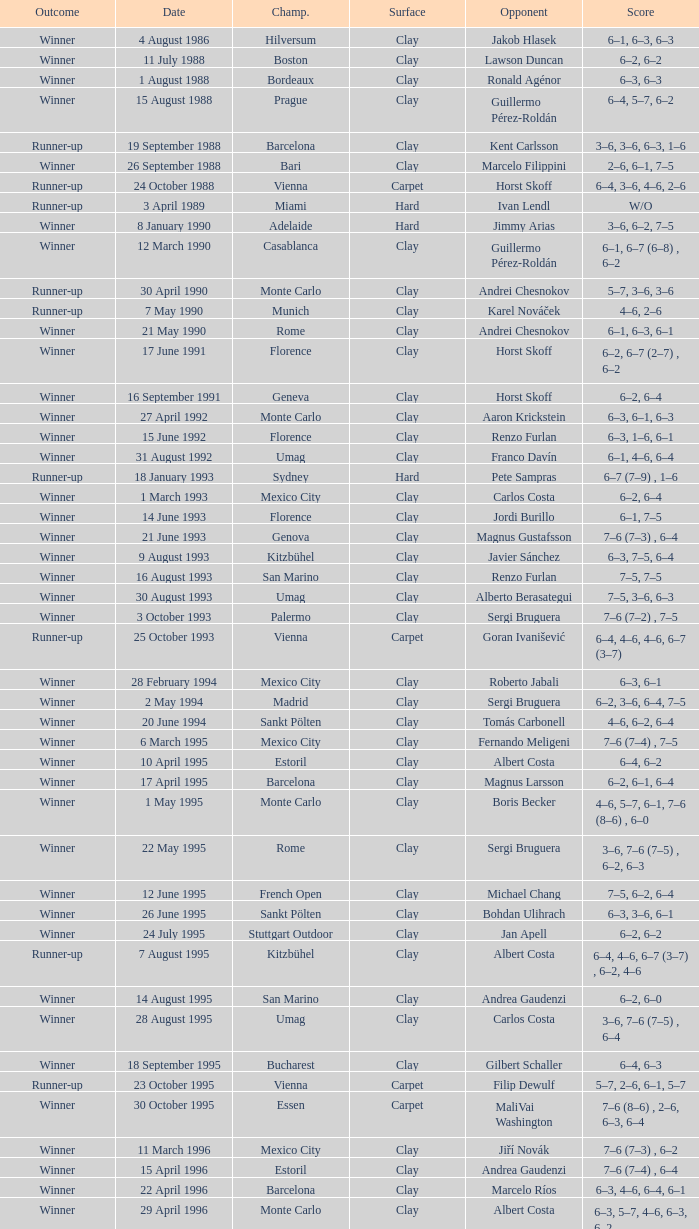Would you be able to parse every entry in this table? {'header': ['Outcome', 'Date', 'Champ.', 'Surface', 'Opponent', 'Score'], 'rows': [['Winner', '4 August 1986', 'Hilversum', 'Clay', 'Jakob Hlasek', '6–1, 6–3, 6–3'], ['Winner', '11 July 1988', 'Boston', 'Clay', 'Lawson Duncan', '6–2, 6–2'], ['Winner', '1 August 1988', 'Bordeaux', 'Clay', 'Ronald Agénor', '6–3, 6–3'], ['Winner', '15 August 1988', 'Prague', 'Clay', 'Guillermo Pérez-Roldán', '6–4, 5–7, 6–2'], ['Runner-up', '19 September 1988', 'Barcelona', 'Clay', 'Kent Carlsson', '3–6, 3–6, 6–3, 1–6'], ['Winner', '26 September 1988', 'Bari', 'Clay', 'Marcelo Filippini', '2–6, 6–1, 7–5'], ['Runner-up', '24 October 1988', 'Vienna', 'Carpet', 'Horst Skoff', '6–4, 3–6, 4–6, 2–6'], ['Runner-up', '3 April 1989', 'Miami', 'Hard', 'Ivan Lendl', 'W/O'], ['Winner', '8 January 1990', 'Adelaide', 'Hard', 'Jimmy Arias', '3–6, 6–2, 7–5'], ['Winner', '12 March 1990', 'Casablanca', 'Clay', 'Guillermo Pérez-Roldán', '6–1, 6–7 (6–8) , 6–2'], ['Runner-up', '30 April 1990', 'Monte Carlo', 'Clay', 'Andrei Chesnokov', '5–7, 3–6, 3–6'], ['Runner-up', '7 May 1990', 'Munich', 'Clay', 'Karel Nováček', '4–6, 2–6'], ['Winner', '21 May 1990', 'Rome', 'Clay', 'Andrei Chesnokov', '6–1, 6–3, 6–1'], ['Winner', '17 June 1991', 'Florence', 'Clay', 'Horst Skoff', '6–2, 6–7 (2–7) , 6–2'], ['Winner', '16 September 1991', 'Geneva', 'Clay', 'Horst Skoff', '6–2, 6–4'], ['Winner', '27 April 1992', 'Monte Carlo', 'Clay', 'Aaron Krickstein', '6–3, 6–1, 6–3'], ['Winner', '15 June 1992', 'Florence', 'Clay', 'Renzo Furlan', '6–3, 1–6, 6–1'], ['Winner', '31 August 1992', 'Umag', 'Clay', 'Franco Davín', '6–1, 4–6, 6–4'], ['Runner-up', '18 January 1993', 'Sydney', 'Hard', 'Pete Sampras', '6–7 (7–9) , 1–6'], ['Winner', '1 March 1993', 'Mexico City', 'Clay', 'Carlos Costa', '6–2, 6–4'], ['Winner', '14 June 1993', 'Florence', 'Clay', 'Jordi Burillo', '6–1, 7–5'], ['Winner', '21 June 1993', 'Genova', 'Clay', 'Magnus Gustafsson', '7–6 (7–3) , 6–4'], ['Winner', '9 August 1993', 'Kitzbühel', 'Clay', 'Javier Sánchez', '6–3, 7–5, 6–4'], ['Winner', '16 August 1993', 'San Marino', 'Clay', 'Renzo Furlan', '7–5, 7–5'], ['Winner', '30 August 1993', 'Umag', 'Clay', 'Alberto Berasategui', '7–5, 3–6, 6–3'], ['Winner', '3 October 1993', 'Palermo', 'Clay', 'Sergi Bruguera', '7–6 (7–2) , 7–5'], ['Runner-up', '25 October 1993', 'Vienna', 'Carpet', 'Goran Ivanišević', '6–4, 4–6, 4–6, 6–7 (3–7)'], ['Winner', '28 February 1994', 'Mexico City', 'Clay', 'Roberto Jabali', '6–3, 6–1'], ['Winner', '2 May 1994', 'Madrid', 'Clay', 'Sergi Bruguera', '6–2, 3–6, 6–4, 7–5'], ['Winner', '20 June 1994', 'Sankt Pölten', 'Clay', 'Tomás Carbonell', '4–6, 6–2, 6–4'], ['Winner', '6 March 1995', 'Mexico City', 'Clay', 'Fernando Meligeni', '7–6 (7–4) , 7–5'], ['Winner', '10 April 1995', 'Estoril', 'Clay', 'Albert Costa', '6–4, 6–2'], ['Winner', '17 April 1995', 'Barcelona', 'Clay', 'Magnus Larsson', '6–2, 6–1, 6–4'], ['Winner', '1 May 1995', 'Monte Carlo', 'Clay', 'Boris Becker', '4–6, 5–7, 6–1, 7–6 (8–6) , 6–0'], ['Winner', '22 May 1995', 'Rome', 'Clay', 'Sergi Bruguera', '3–6, 7–6 (7–5) , 6–2, 6–3'], ['Winner', '12 June 1995', 'French Open', 'Clay', 'Michael Chang', '7–5, 6–2, 6–4'], ['Winner', '26 June 1995', 'Sankt Pölten', 'Clay', 'Bohdan Ulihrach', '6–3, 3–6, 6–1'], ['Winner', '24 July 1995', 'Stuttgart Outdoor', 'Clay', 'Jan Apell', '6–2, 6–2'], ['Runner-up', '7 August 1995', 'Kitzbühel', 'Clay', 'Albert Costa', '6–4, 4–6, 6–7 (3–7) , 6–2, 4–6'], ['Winner', '14 August 1995', 'San Marino', 'Clay', 'Andrea Gaudenzi', '6–2, 6–0'], ['Winner', '28 August 1995', 'Umag', 'Clay', 'Carlos Costa', '3–6, 7–6 (7–5) , 6–4'], ['Winner', '18 September 1995', 'Bucharest', 'Clay', 'Gilbert Schaller', '6–4, 6–3'], ['Runner-up', '23 October 1995', 'Vienna', 'Carpet', 'Filip Dewulf', '5–7, 2–6, 6–1, 5–7'], ['Winner', '30 October 1995', 'Essen', 'Carpet', 'MaliVai Washington', '7–6 (8–6) , 2–6, 6–3, 6–4'], ['Winner', '11 March 1996', 'Mexico City', 'Clay', 'Jiří Novák', '7–6 (7–3) , 6–2'], ['Winner', '15 April 1996', 'Estoril', 'Clay', 'Andrea Gaudenzi', '7–6 (7–4) , 6–4'], ['Winner', '22 April 1996', 'Barcelona', 'Clay', 'Marcelo Ríos', '6–3, 4–6, 6–4, 6–1'], ['Winner', '29 April 1996', 'Monte Carlo', 'Clay', 'Albert Costa', '6–3, 5–7, 4–6, 6–3, 6–2'], ['Winner', '20 May 1996', 'Rome', 'Clay', 'Richard Krajicek', '6–2, 6–4, 3–6, 6–3'], ['Winner', '22 July 1996', 'Stuttgart Outdoor', 'Clay', 'Yevgeny Kafelnikov', '6–2, 6–2, 6–4'], ['Winner', '16 September 1996', 'Bogotá', 'Clay', 'Nicolás Lapentti', '6–7 (6–8) , 6–2, 6–3'], ['Winner', '17 February 1997', 'Dubai', 'Hard', 'Goran Ivanišević', '7–5, 7–6 (7–3)'], ['Winner', '31 March 1997', 'Miami', 'Hard', 'Sergi Bruguera', '7–6 (8–6) , 6–3, 6–1'], ['Runner-up', '11 August 1997', 'Cincinnati', 'Hard', 'Pete Sampras', '3–6, 4–6'], ['Runner-up', '13 April 1998', 'Estoril', 'Clay', 'Alberto Berasategui', '6–3, 1–6, 3–6']]} What is the score when the outcome is winner against yevgeny kafelnikov? 6–2, 6–2, 6–4. 